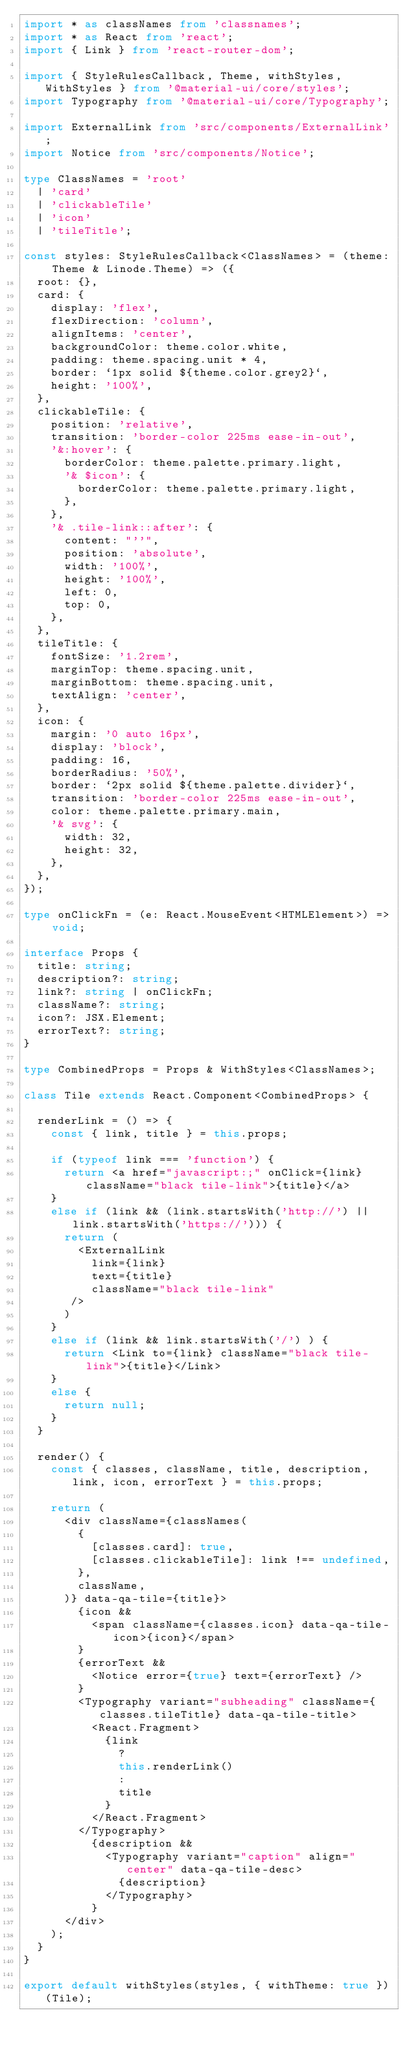<code> <loc_0><loc_0><loc_500><loc_500><_TypeScript_>import * as classNames from 'classnames';
import * as React from 'react';
import { Link } from 'react-router-dom';

import { StyleRulesCallback, Theme, withStyles, WithStyles } from '@material-ui/core/styles';
import Typography from '@material-ui/core/Typography';

import ExternalLink from 'src/components/ExternalLink';
import Notice from 'src/components/Notice';

type ClassNames = 'root'
  | 'card'
  | 'clickableTile'
  | 'icon'
  | 'tileTitle';

const styles: StyleRulesCallback<ClassNames> = (theme: Theme & Linode.Theme) => ({
  root: {},
  card: {
    display: 'flex',
    flexDirection: 'column',
    alignItems: 'center',
    backgroundColor: theme.color.white,
    padding: theme.spacing.unit * 4,
    border: `1px solid ${theme.color.grey2}`,
    height: '100%',
  },
  clickableTile: {
    position: 'relative',
    transition: 'border-color 225ms ease-in-out',
    '&:hover': {
      borderColor: theme.palette.primary.light,
      '& $icon': {
        borderColor: theme.palette.primary.light,
      },
    },
    '& .tile-link::after': {
      content: "''",
      position: 'absolute',
      width: '100%',
      height: '100%',
      left: 0,
      top: 0,
    },
  },
  tileTitle: {
    fontSize: '1.2rem',
    marginTop: theme.spacing.unit,
    marginBottom: theme.spacing.unit,
    textAlign: 'center',
  },
  icon: {
    margin: '0 auto 16px',
    display: 'block',
    padding: 16,
    borderRadius: '50%',
    border: `2px solid ${theme.palette.divider}`,
    transition: 'border-color 225ms ease-in-out',
    color: theme.palette.primary.main,
    '& svg': {
      width: 32,
      height: 32,
    },
  },
});

type onClickFn = (e: React.MouseEvent<HTMLElement>) => void;

interface Props {
  title: string;
  description?: string;
  link?: string | onClickFn;
  className?: string;
  icon?: JSX.Element;
  errorText?: string;
}

type CombinedProps = Props & WithStyles<ClassNames>;

class Tile extends React.Component<CombinedProps> {

  renderLink = () => {
    const { link, title } = this.props;

    if (typeof link === 'function') {
      return <a href="javascript:;" onClick={link} className="black tile-link">{title}</a>
    }
    else if (link && (link.startsWith('http://') || link.startsWith('https://'))) {
      return (
        <ExternalLink
          link={link}
          text={title}
          className="black tile-link"
       />
      )
    }
    else if (link && link.startsWith('/') ) {
      return <Link to={link} className="black tile-link">{title}</Link>
    }
    else {
      return null;
    }
  }

  render() {
    const { classes, className, title, description, link, icon, errorText } = this.props;

    return (
      <div className={classNames(
        {
          [classes.card]: true,
          [classes.clickableTile]: link !== undefined,
        },
        className,
      )} data-qa-tile={title}>
        {icon &&
          <span className={classes.icon} data-qa-tile-icon>{icon}</span>
        }
        {errorText &&
          <Notice error={true} text={errorText} />
        }
        <Typography variant="subheading" className={classes.tileTitle} data-qa-tile-title>
          <React.Fragment>
            {link
              ?
              this.renderLink()
              :
              title
            }
          </React.Fragment>
        </Typography>
          {description &&
            <Typography variant="caption" align="center" data-qa-tile-desc>
              {description}
            </Typography>
          }
      </div>
    );
  }
}

export default withStyles(styles, { withTheme: true })(Tile);
</code> 